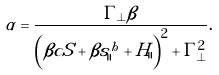Convert formula to latex. <formula><loc_0><loc_0><loc_500><loc_500>\alpha = \frac { \Gamma _ { \perp } \beta } { \left ( \beta c S + \beta s ^ { h } _ { \| } + H _ { \| } \right ) ^ { 2 } + \Gamma _ { \perp } ^ { 2 } } .</formula> 